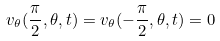<formula> <loc_0><loc_0><loc_500><loc_500>v _ { \theta } ( \frac { \pi } { 2 } , \theta , t ) = v _ { \theta } ( - \frac { \pi } { 2 } , \theta , t ) = 0</formula> 